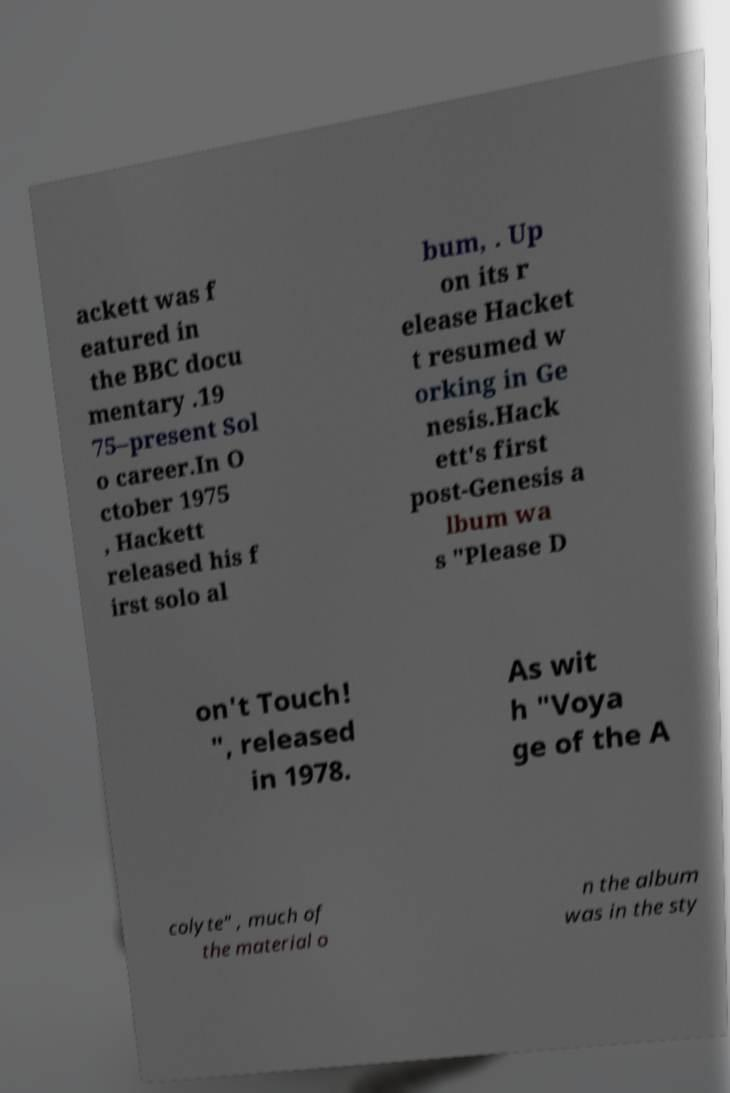What messages or text are displayed in this image? I need them in a readable, typed format. ackett was f eatured in the BBC docu mentary .19 75–present Sol o career.In O ctober 1975 , Hackett released his f irst solo al bum, . Up on its r elease Hacket t resumed w orking in Ge nesis.Hack ett's first post-Genesis a lbum wa s "Please D on't Touch! ", released in 1978. As wit h "Voya ge of the A colyte" , much of the material o n the album was in the sty 